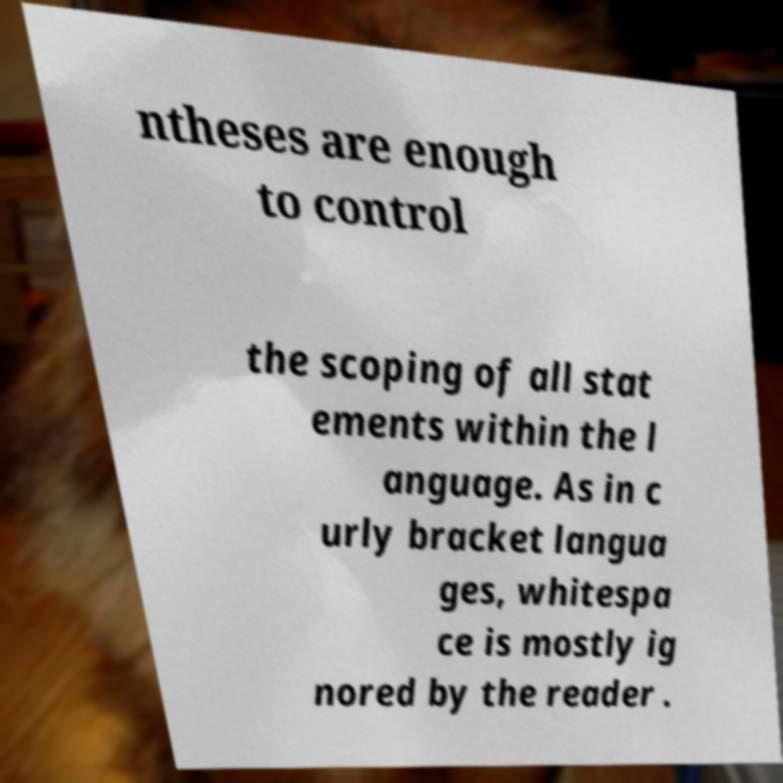Please identify and transcribe the text found in this image. ntheses are enough to control the scoping of all stat ements within the l anguage. As in c urly bracket langua ges, whitespa ce is mostly ig nored by the reader . 